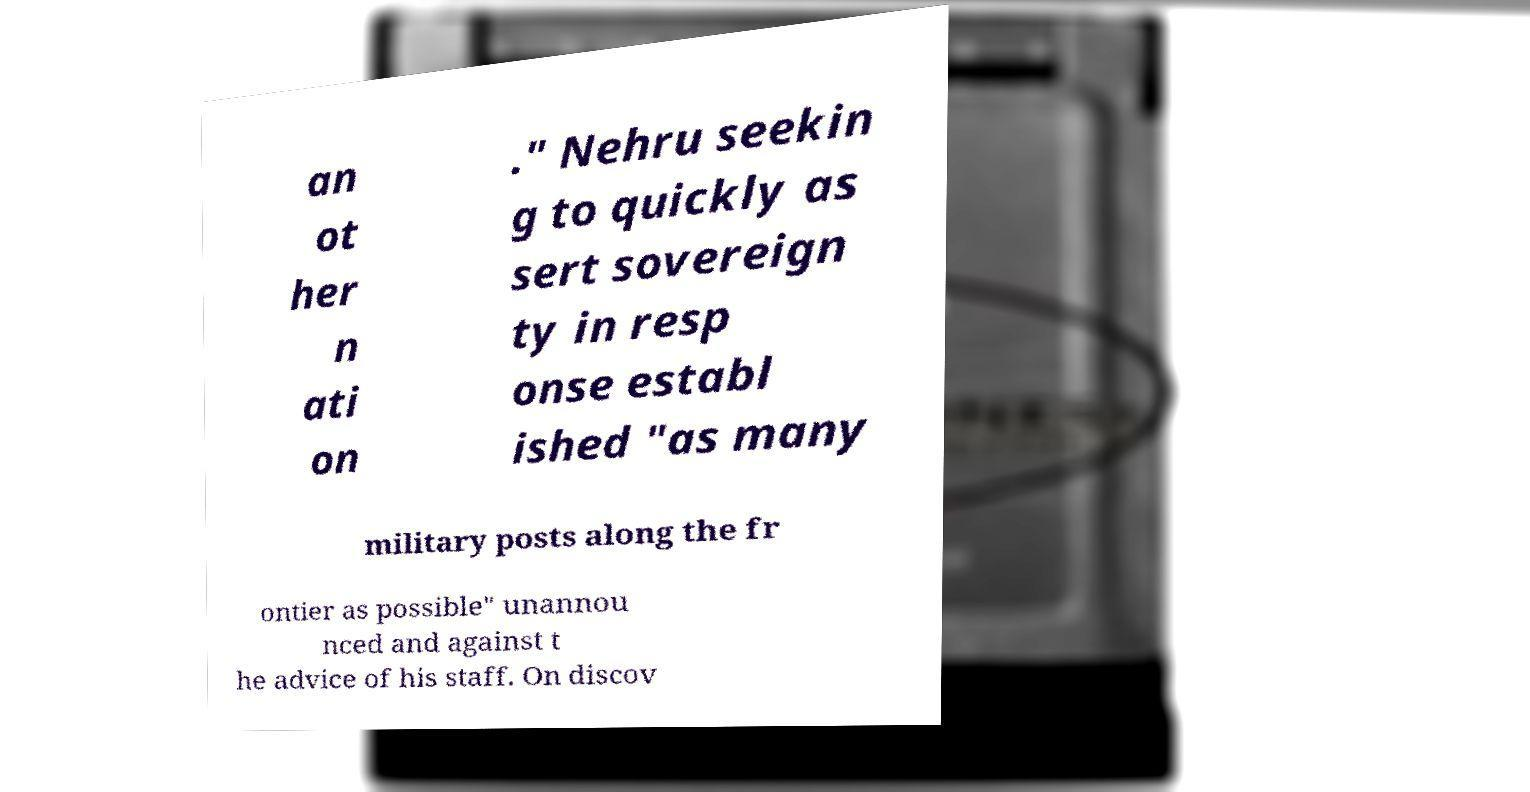Can you accurately transcribe the text from the provided image for me? an ot her n ati on ." Nehru seekin g to quickly as sert sovereign ty in resp onse establ ished "as many military posts along the fr ontier as possible" unannou nced and against t he advice of his staff. On discov 